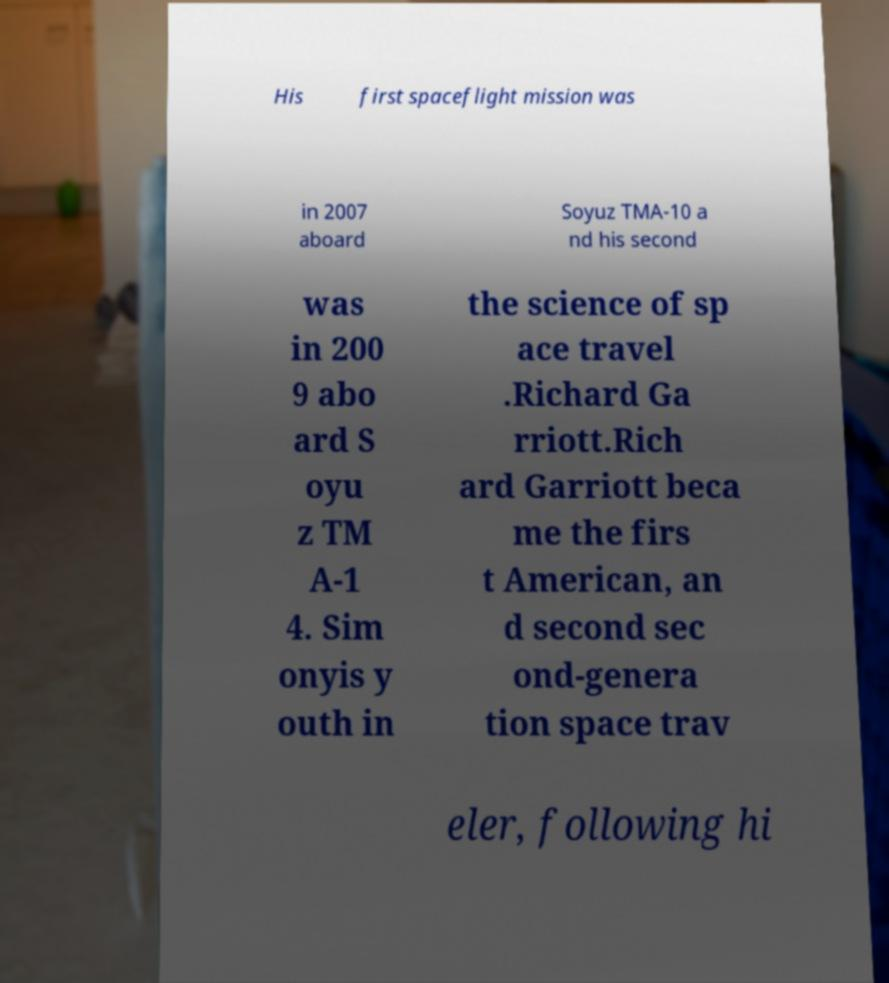Could you extract and type out the text from this image? His first spaceflight mission was in 2007 aboard Soyuz TMA-10 a nd his second was in 200 9 abo ard S oyu z TM A-1 4. Sim onyis y outh in the science of sp ace travel .Richard Ga rriott.Rich ard Garriott beca me the firs t American, an d second sec ond-genera tion space trav eler, following hi 